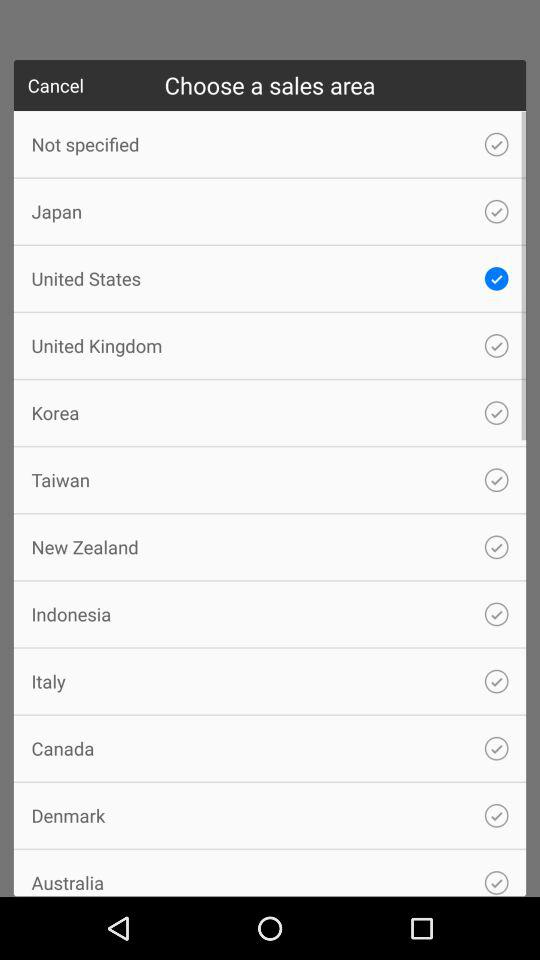Which is the selected sales area? The selected sales area is United States. 